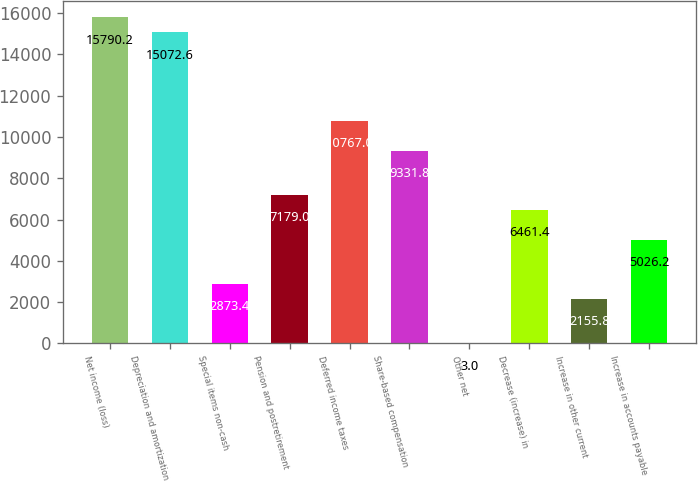Convert chart. <chart><loc_0><loc_0><loc_500><loc_500><bar_chart><fcel>Net income (loss)<fcel>Depreciation and amortization<fcel>Special items non-cash<fcel>Pension and postretirement<fcel>Deferred income taxes<fcel>Share-based compensation<fcel>Other net<fcel>Decrease (increase) in<fcel>Increase in other current<fcel>Increase in accounts payable<nl><fcel>15790.2<fcel>15072.6<fcel>2873.4<fcel>7179<fcel>10767<fcel>9331.8<fcel>3<fcel>6461.4<fcel>2155.8<fcel>5026.2<nl></chart> 